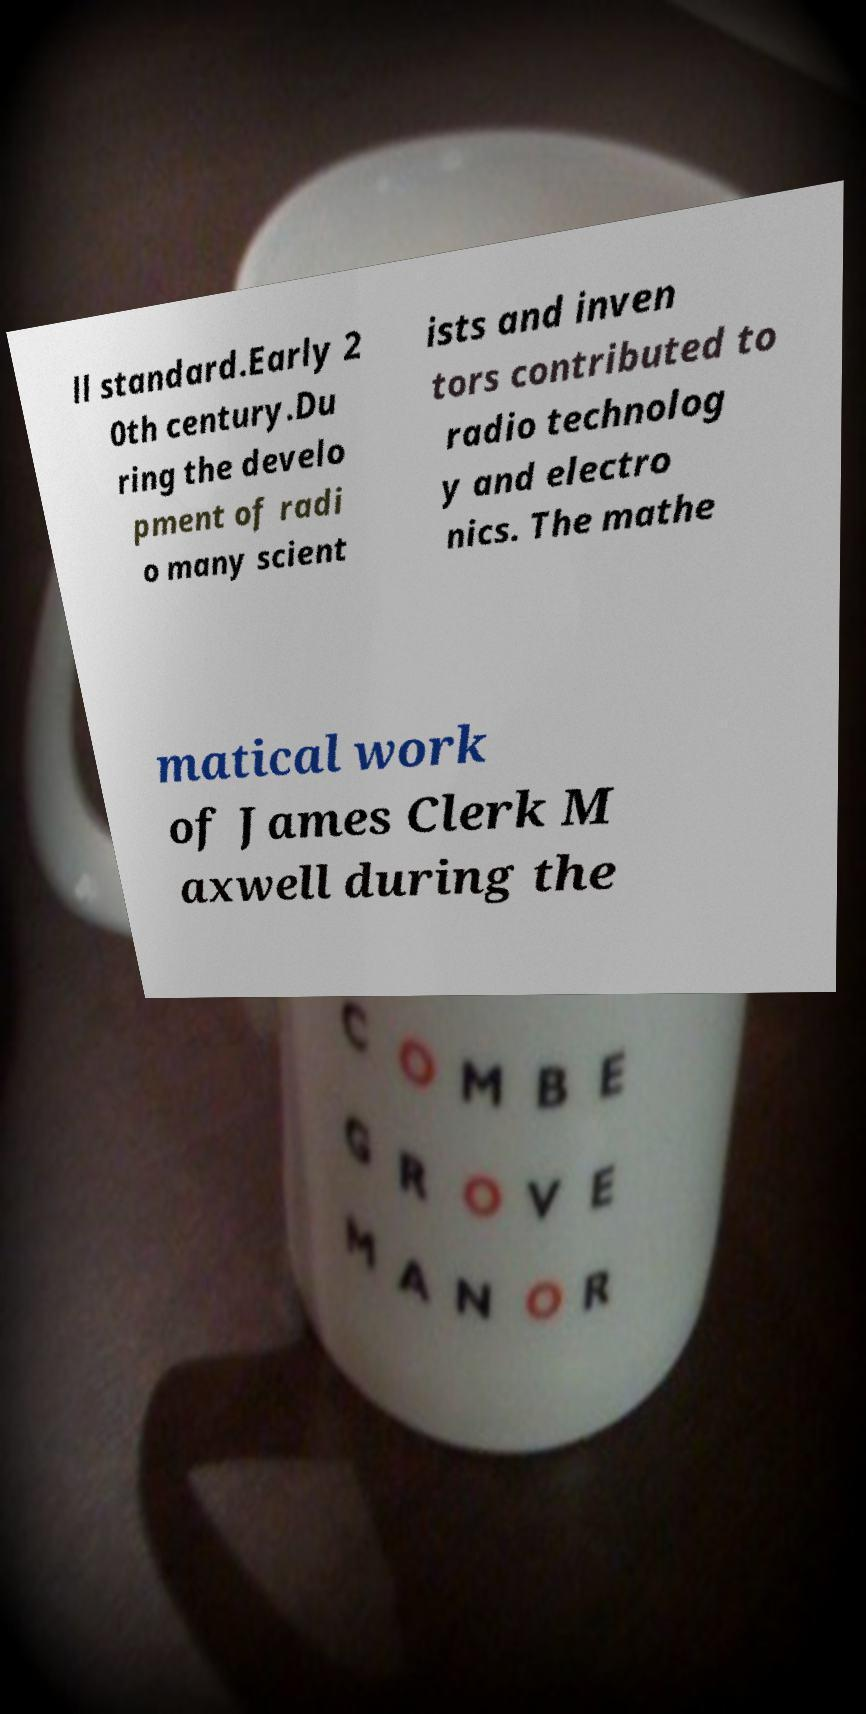Please read and relay the text visible in this image. What does it say? ll standard.Early 2 0th century.Du ring the develo pment of radi o many scient ists and inven tors contributed to radio technolog y and electro nics. The mathe matical work of James Clerk M axwell during the 